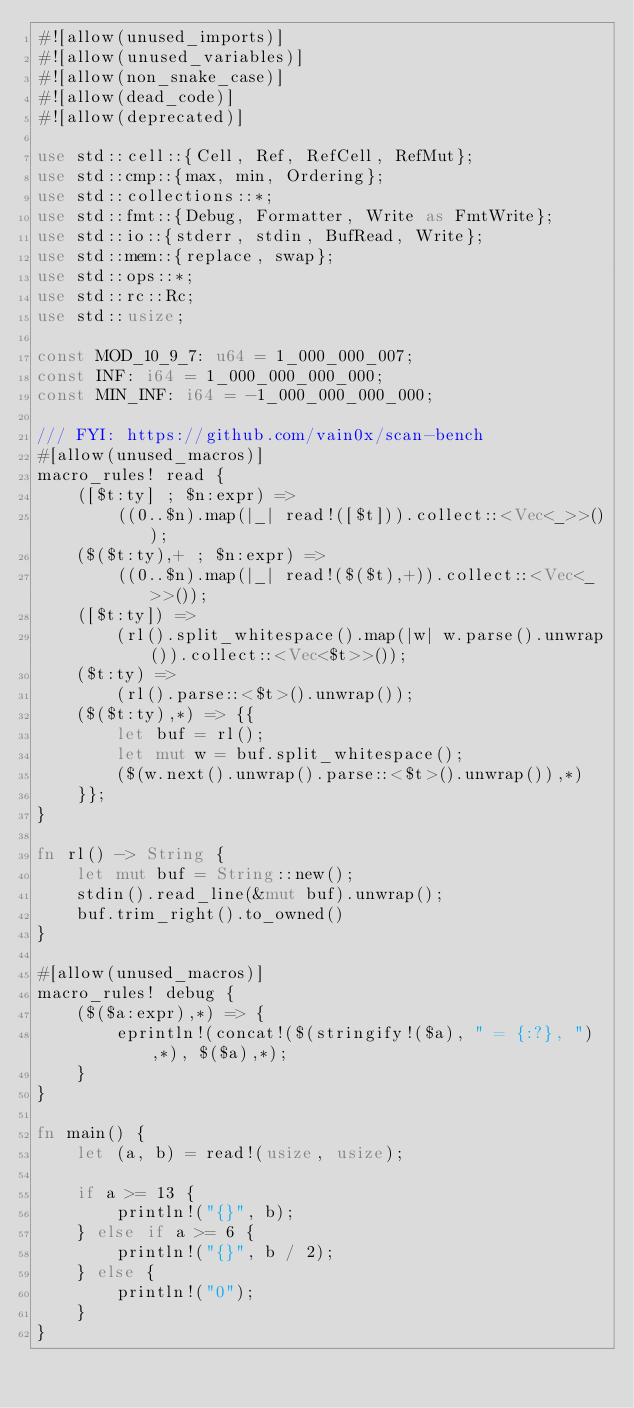Convert code to text. <code><loc_0><loc_0><loc_500><loc_500><_Rust_>#![allow(unused_imports)]
#![allow(unused_variables)]
#![allow(non_snake_case)]
#![allow(dead_code)]
#![allow(deprecated)]

use std::cell::{Cell, Ref, RefCell, RefMut};
use std::cmp::{max, min, Ordering};
use std::collections::*;
use std::fmt::{Debug, Formatter, Write as FmtWrite};
use std::io::{stderr, stdin, BufRead, Write};
use std::mem::{replace, swap};
use std::ops::*;
use std::rc::Rc;
use std::usize;

const MOD_10_9_7: u64 = 1_000_000_007;
const INF: i64 = 1_000_000_000_000;
const MIN_INF: i64 = -1_000_000_000_000;

/// FYI: https://github.com/vain0x/scan-bench
#[allow(unused_macros)]
macro_rules! read {
    ([$t:ty] ; $n:expr) =>
        ((0..$n).map(|_| read!([$t])).collect::<Vec<_>>());
    ($($t:ty),+ ; $n:expr) =>
        ((0..$n).map(|_| read!($($t),+)).collect::<Vec<_>>());
    ([$t:ty]) =>
        (rl().split_whitespace().map(|w| w.parse().unwrap()).collect::<Vec<$t>>());
    ($t:ty) =>
        (rl().parse::<$t>().unwrap());
    ($($t:ty),*) => {{
        let buf = rl();
        let mut w = buf.split_whitespace();
        ($(w.next().unwrap().parse::<$t>().unwrap()),*)
    }};
}

fn rl() -> String {
    let mut buf = String::new();
    stdin().read_line(&mut buf).unwrap();
    buf.trim_right().to_owned()
}

#[allow(unused_macros)]
macro_rules! debug {
    ($($a:expr),*) => {
        eprintln!(concat!($(stringify!($a), " = {:?}, "),*), $($a),*);
    }
}

fn main() {
    let (a, b) = read!(usize, usize);

    if a >= 13 {
        println!("{}", b);
    } else if a >= 6 {
        println!("{}", b / 2);
    } else {
        println!("0");
    }
}
</code> 